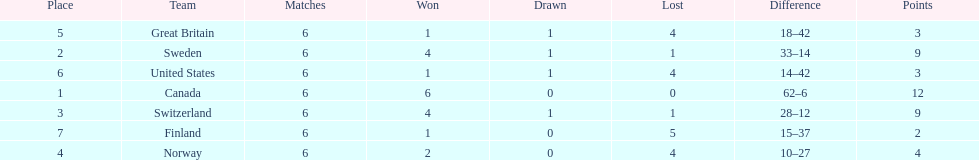Would you mind parsing the complete table? {'header': ['Place', 'Team', 'Matches', 'Won', 'Drawn', 'Lost', 'Difference', 'Points'], 'rows': [['5', 'Great Britain', '6', '1', '1', '4', '18–42', '3'], ['2', 'Sweden', '6', '4', '1', '1', '33–14', '9'], ['6', 'United States', '6', '1', '1', '4', '14–42', '3'], ['1', 'Canada', '6', '6', '0', '0', '62–6', '12'], ['3', 'Switzerland', '6', '4', '1', '1', '28–12', '9'], ['7', 'Finland', '6', '1', '0', '5', '15–37', '2'], ['4', 'Norway', '6', '2', '0', '4', '10–27', '4']]} How many teams won 6 matches? 1. 